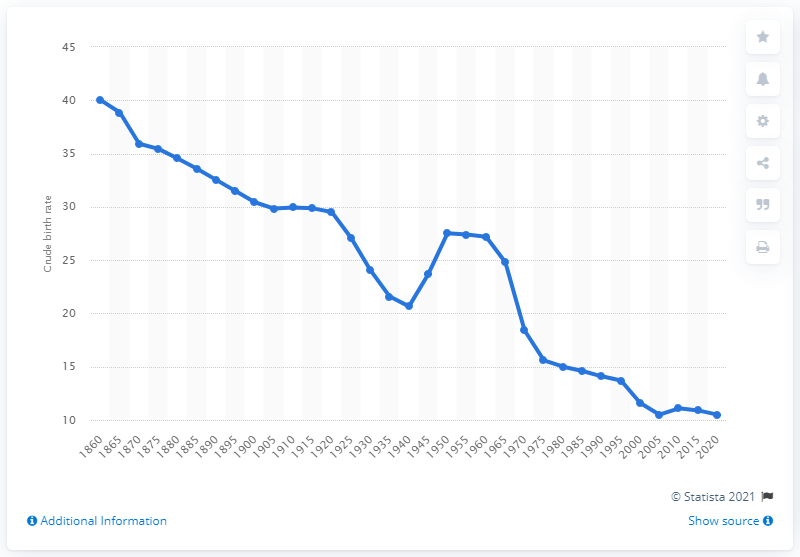Specify some key components in this picture. According to projections, the crude birth rate of Canada is expected to hit its lowest point in the year 2020. 